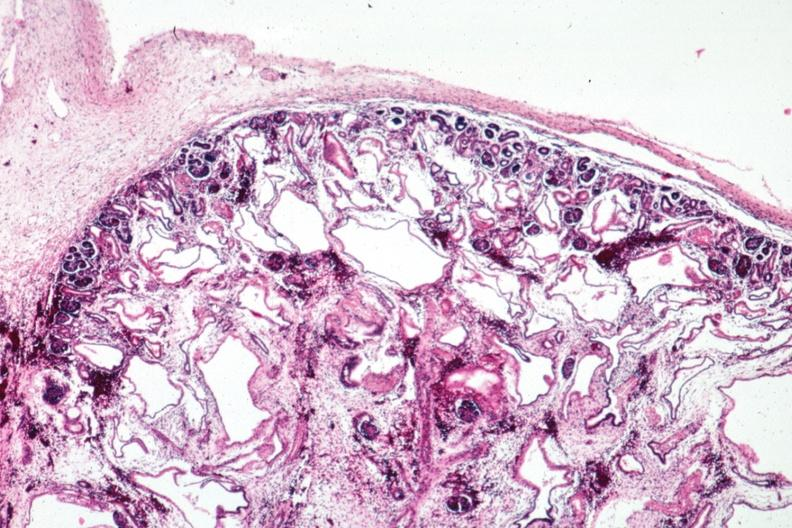s polycystic disease infant present?
Answer the question using a single word or phrase. Yes 